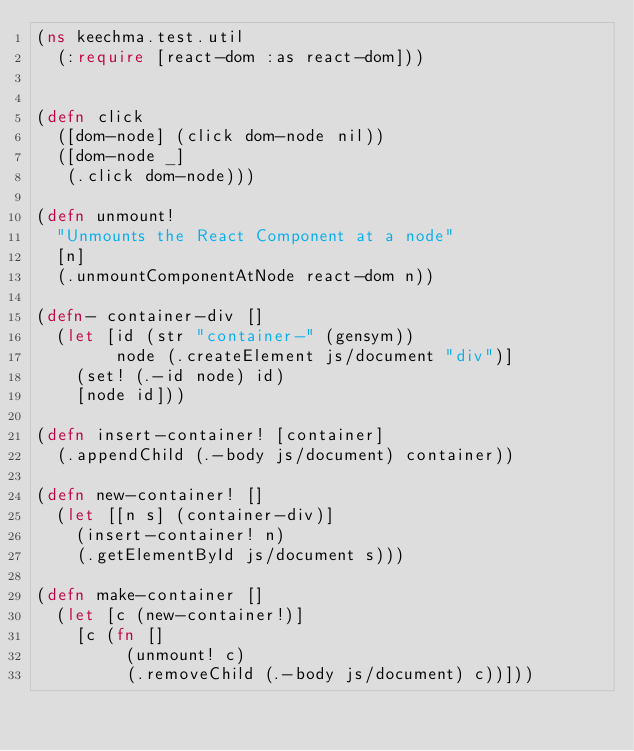<code> <loc_0><loc_0><loc_500><loc_500><_Clojure_>(ns keechma.test.util
  (:require [react-dom :as react-dom]))


(defn click
  ([dom-node] (click dom-node nil))
  ([dom-node _]
   (.click dom-node)))

(defn unmount!
  "Unmounts the React Component at a node"
  [n]
  (.unmountComponentAtNode react-dom n))

(defn- container-div []
  (let [id (str "container-" (gensym))
        node (.createElement js/document "div")]
    (set! (.-id node) id)
    [node id]))

(defn insert-container! [container]
  (.appendChild (.-body js/document) container))

(defn new-container! []
  (let [[n s] (container-div)]
    (insert-container! n)
    (.getElementById js/document s)))

(defn make-container []
  (let [c (new-container!)]
    [c (fn []
         (unmount! c)
         (.removeChild (.-body js/document) c))]))
</code> 